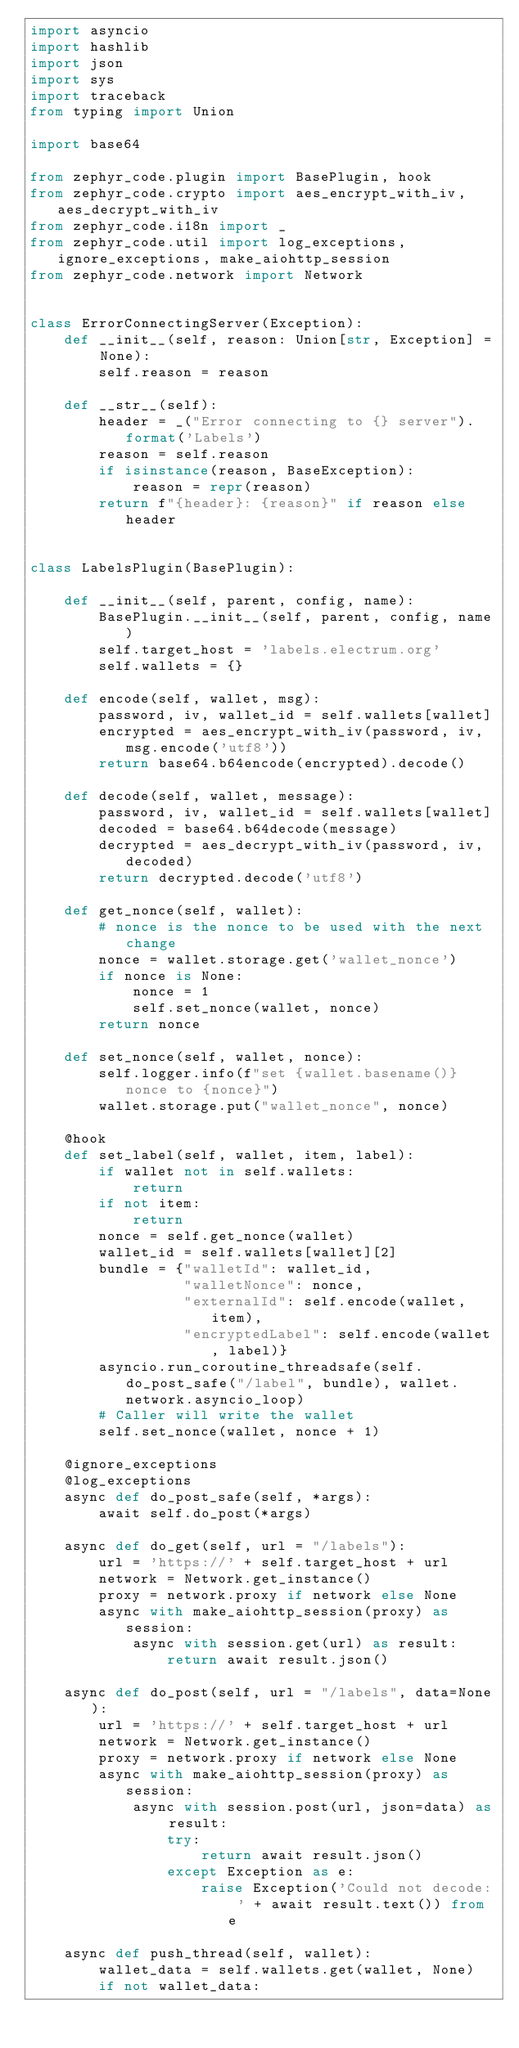<code> <loc_0><loc_0><loc_500><loc_500><_Python_>import asyncio
import hashlib
import json
import sys
import traceback
from typing import Union

import base64

from zephyr_code.plugin import BasePlugin, hook
from zephyr_code.crypto import aes_encrypt_with_iv, aes_decrypt_with_iv
from zephyr_code.i18n import _
from zephyr_code.util import log_exceptions, ignore_exceptions, make_aiohttp_session
from zephyr_code.network import Network


class ErrorConnectingServer(Exception):
    def __init__(self, reason: Union[str, Exception] = None):
        self.reason = reason

    def __str__(self):
        header = _("Error connecting to {} server").format('Labels')
        reason = self.reason
        if isinstance(reason, BaseException):
            reason = repr(reason)
        return f"{header}: {reason}" if reason else header


class LabelsPlugin(BasePlugin):

    def __init__(self, parent, config, name):
        BasePlugin.__init__(self, parent, config, name)
        self.target_host = 'labels.electrum.org'
        self.wallets = {}

    def encode(self, wallet, msg):
        password, iv, wallet_id = self.wallets[wallet]
        encrypted = aes_encrypt_with_iv(password, iv, msg.encode('utf8'))
        return base64.b64encode(encrypted).decode()

    def decode(self, wallet, message):
        password, iv, wallet_id = self.wallets[wallet]
        decoded = base64.b64decode(message)
        decrypted = aes_decrypt_with_iv(password, iv, decoded)
        return decrypted.decode('utf8')

    def get_nonce(self, wallet):
        # nonce is the nonce to be used with the next change
        nonce = wallet.storage.get('wallet_nonce')
        if nonce is None:
            nonce = 1
            self.set_nonce(wallet, nonce)
        return nonce

    def set_nonce(self, wallet, nonce):
        self.logger.info(f"set {wallet.basename()} nonce to {nonce}")
        wallet.storage.put("wallet_nonce", nonce)

    @hook
    def set_label(self, wallet, item, label):
        if wallet not in self.wallets:
            return
        if not item:
            return
        nonce = self.get_nonce(wallet)
        wallet_id = self.wallets[wallet][2]
        bundle = {"walletId": wallet_id,
                  "walletNonce": nonce,
                  "externalId": self.encode(wallet, item),
                  "encryptedLabel": self.encode(wallet, label)}
        asyncio.run_coroutine_threadsafe(self.do_post_safe("/label", bundle), wallet.network.asyncio_loop)
        # Caller will write the wallet
        self.set_nonce(wallet, nonce + 1)

    @ignore_exceptions
    @log_exceptions
    async def do_post_safe(self, *args):
        await self.do_post(*args)

    async def do_get(self, url = "/labels"):
        url = 'https://' + self.target_host + url
        network = Network.get_instance()
        proxy = network.proxy if network else None
        async with make_aiohttp_session(proxy) as session:
            async with session.get(url) as result:
                return await result.json()

    async def do_post(self, url = "/labels", data=None):
        url = 'https://' + self.target_host + url
        network = Network.get_instance()
        proxy = network.proxy if network else None
        async with make_aiohttp_session(proxy) as session:
            async with session.post(url, json=data) as result:
                try:
                    return await result.json()
                except Exception as e:
                    raise Exception('Could not decode: ' + await result.text()) from e

    async def push_thread(self, wallet):
        wallet_data = self.wallets.get(wallet, None)
        if not wallet_data:</code> 